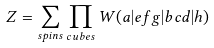Convert formula to latex. <formula><loc_0><loc_0><loc_500><loc_500>Z = \sum _ { s p i n s } \prod _ { c u b e s } W ( a | e f g | b c d | h )</formula> 